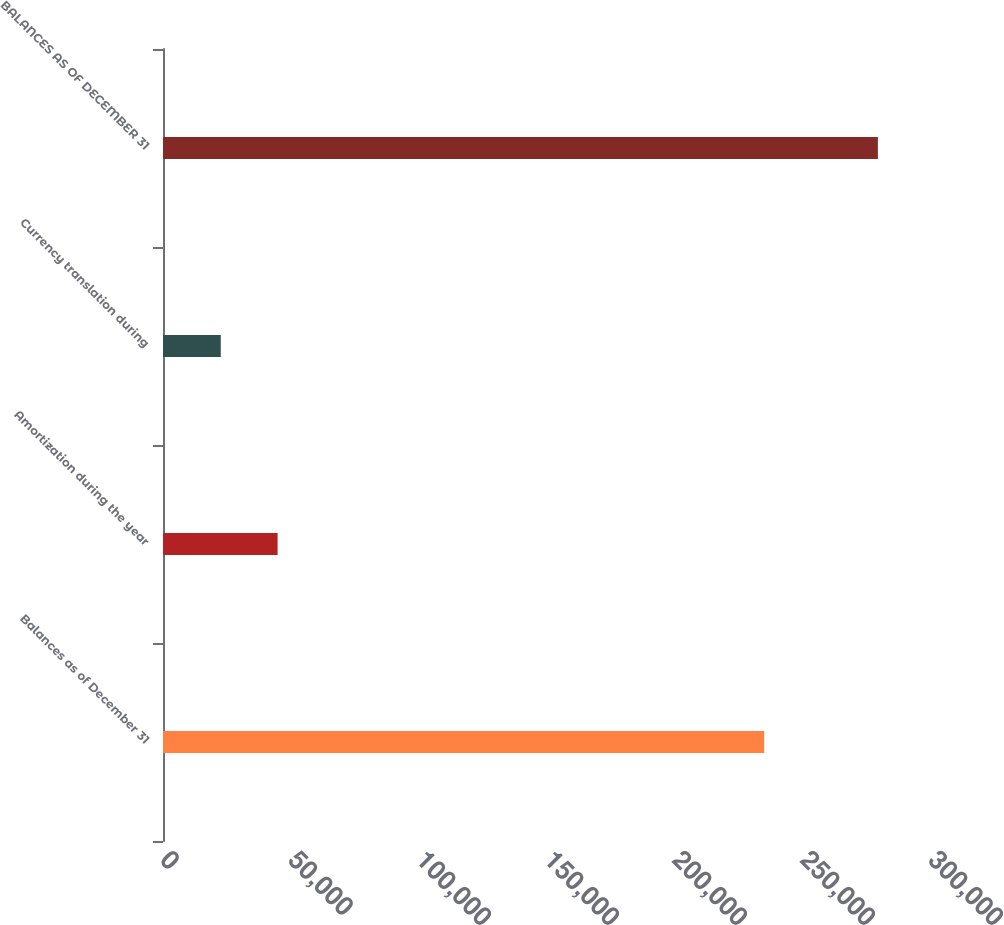<chart> <loc_0><loc_0><loc_500><loc_500><bar_chart><fcel>Balances as of December 31<fcel>Amortization during the year<fcel>Currency translation during<fcel>BALANCES AS OF DECEMBER 31<nl><fcel>234835<fcel>44765<fcel>22558<fcel>279249<nl></chart> 